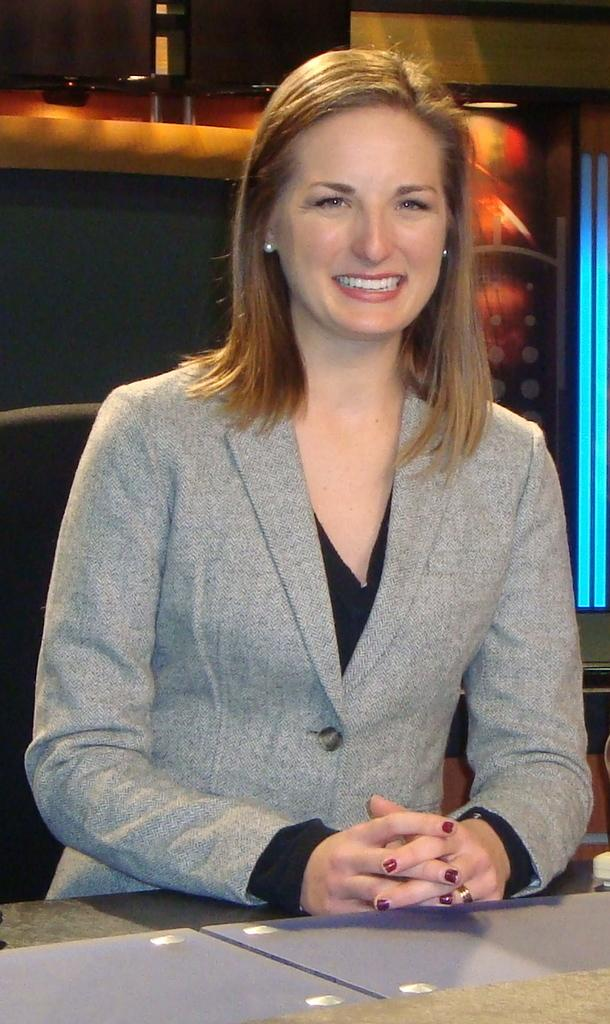Who is present in the image? There is a woman in the image. What is the woman doing in the image? The woman is sitting on a chair. Where is the chair located in relation to the table? The chair is in front of a table. What can be seen in the background of the image? The background includes objects and a wall. What type of location might the image have been taken in? The image may have been taken in a hall. What time of day is it in the image, considering the afternoon? The time of day cannot be determined from the image, as there is no indication of the time or lighting that would suggest it is afternoon. 